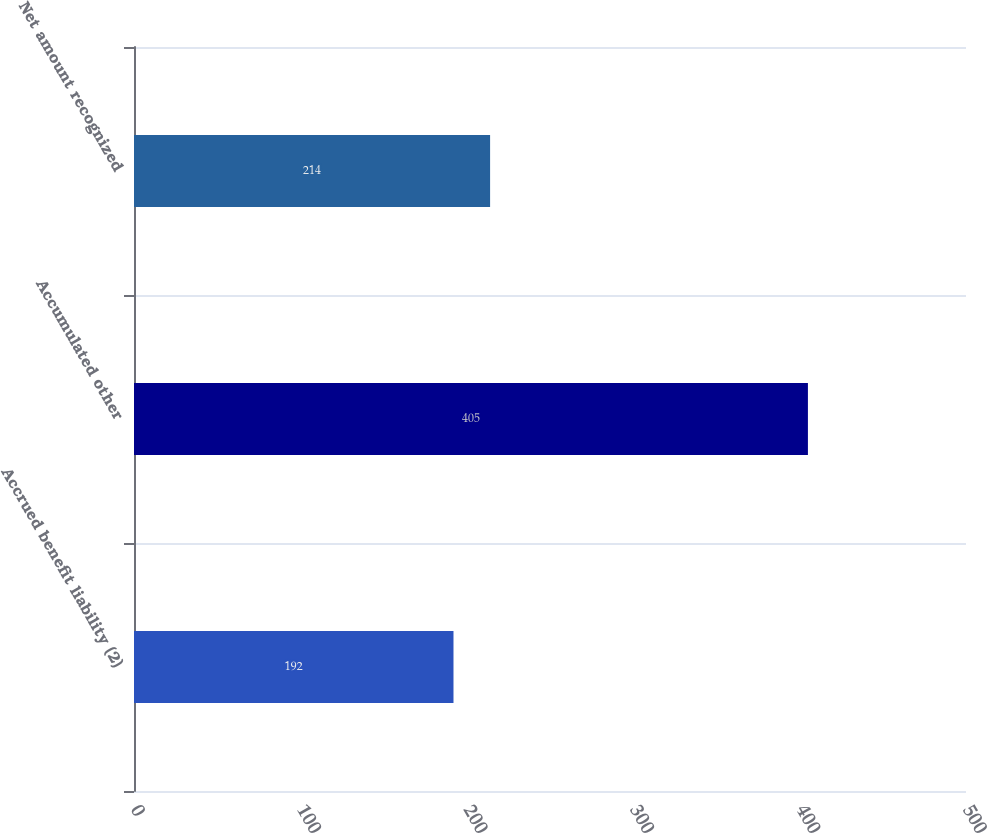<chart> <loc_0><loc_0><loc_500><loc_500><bar_chart><fcel>Accrued benefit liability (2)<fcel>Accumulated other<fcel>Net amount recognized<nl><fcel>192<fcel>405<fcel>214<nl></chart> 